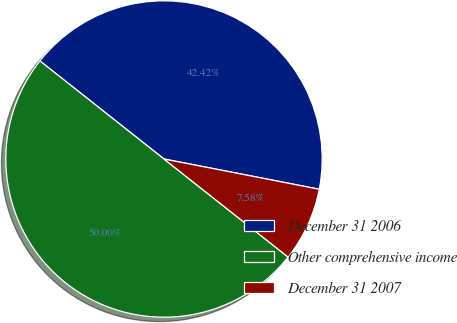<chart> <loc_0><loc_0><loc_500><loc_500><pie_chart><fcel>December 31 2006<fcel>Other comprehensive income<fcel>December 31 2007<nl><fcel>42.42%<fcel>50.0%<fcel>7.58%<nl></chart> 